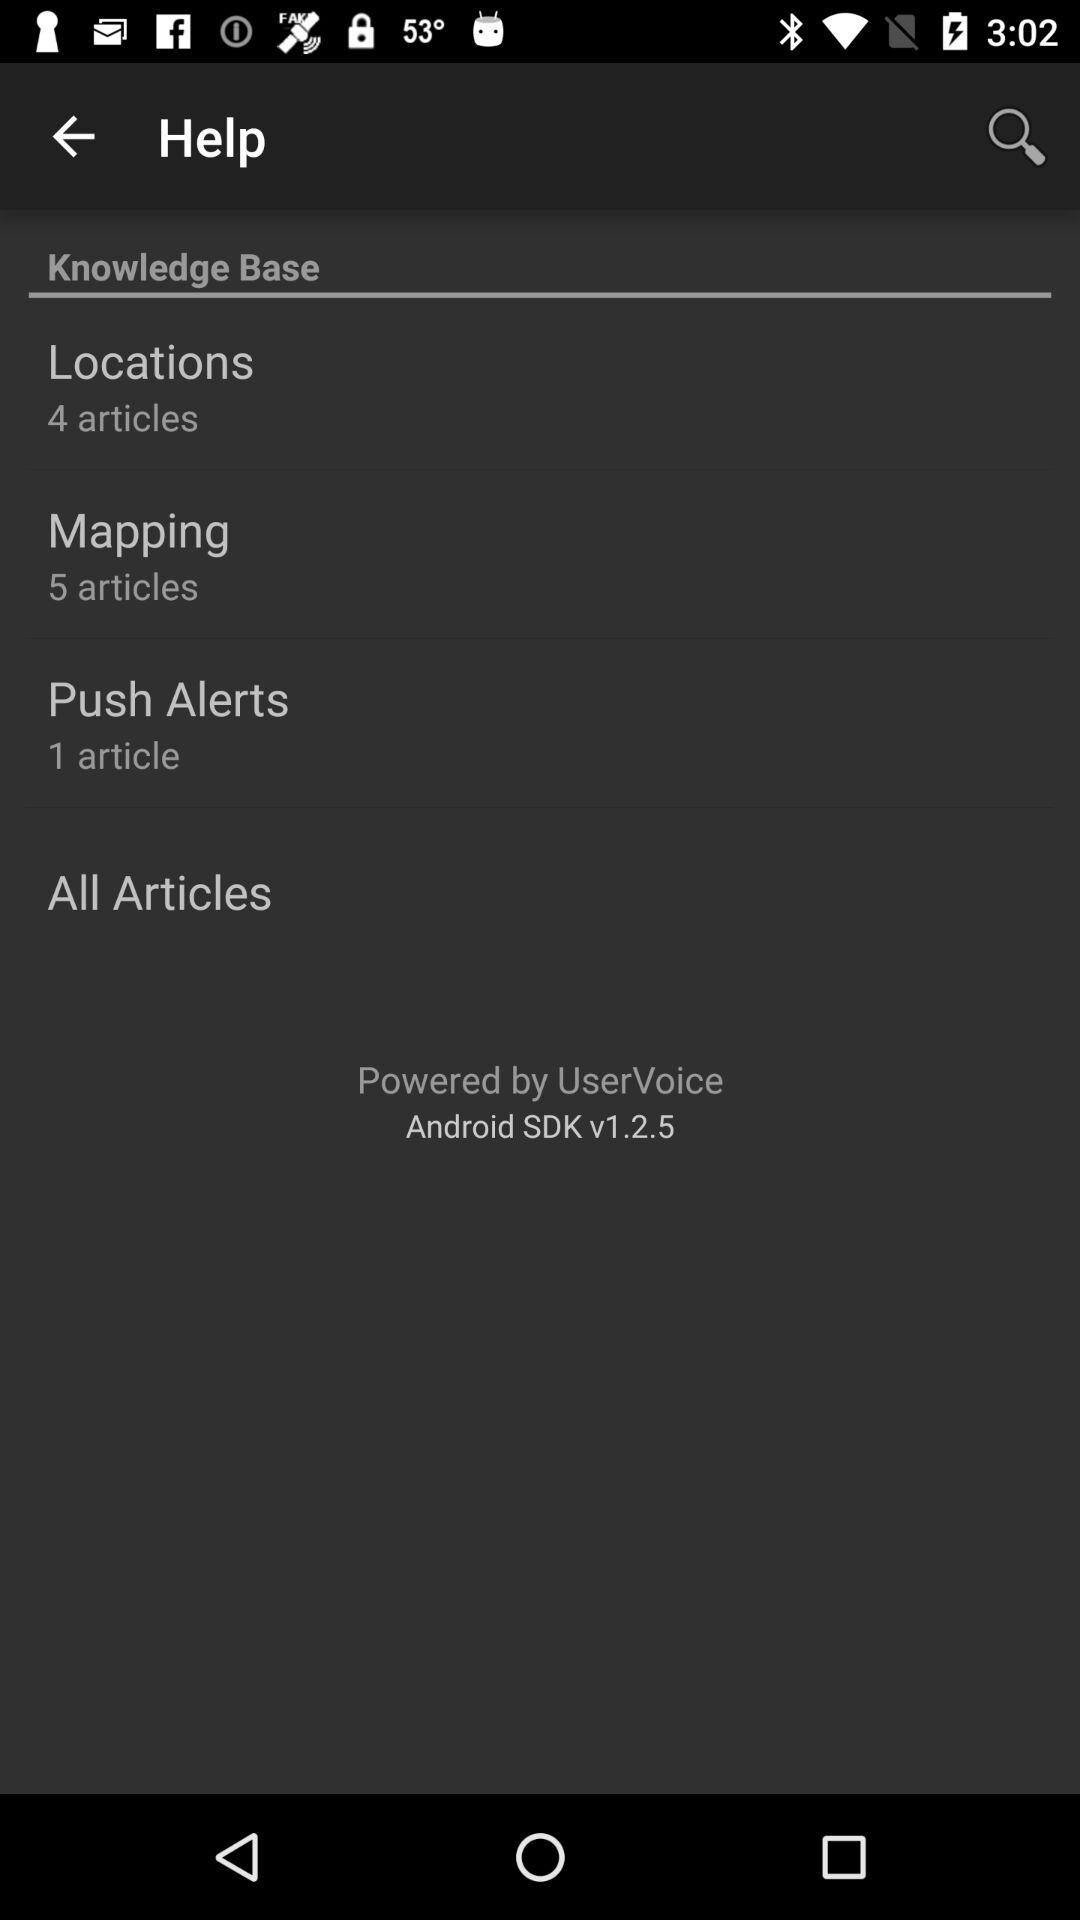How many articles are there in the Knowledge Base?
Answer the question using a single word or phrase. 10 